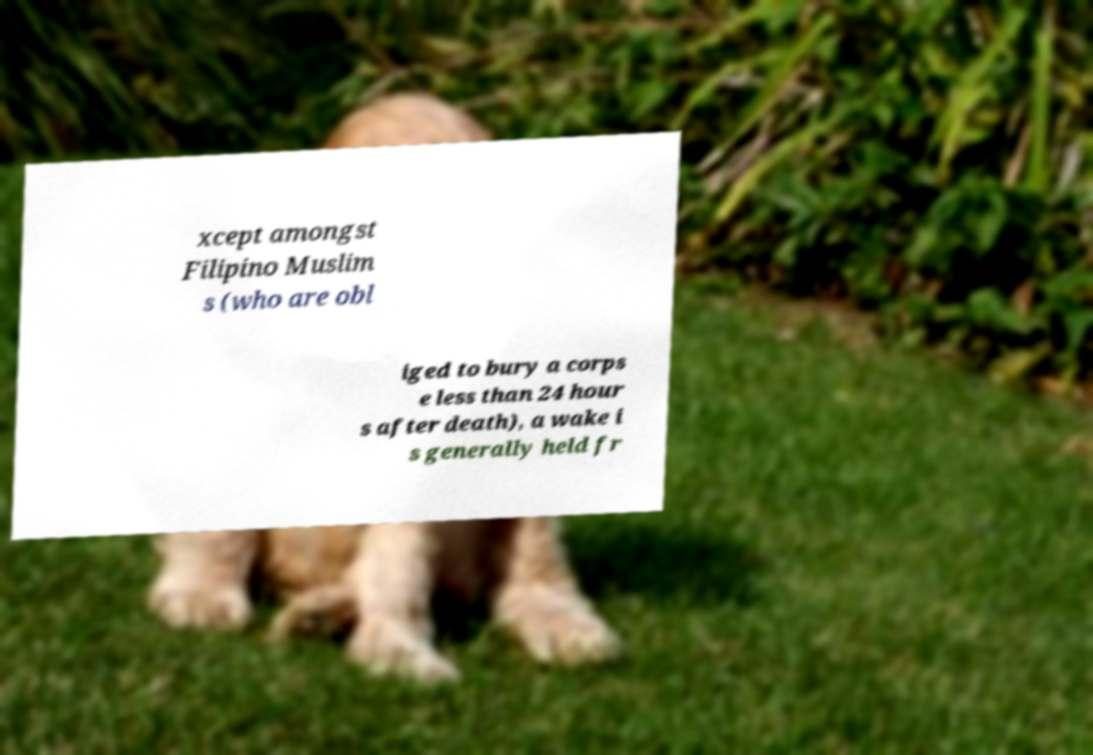There's text embedded in this image that I need extracted. Can you transcribe it verbatim? xcept amongst Filipino Muslim s (who are obl iged to bury a corps e less than 24 hour s after death), a wake i s generally held fr 